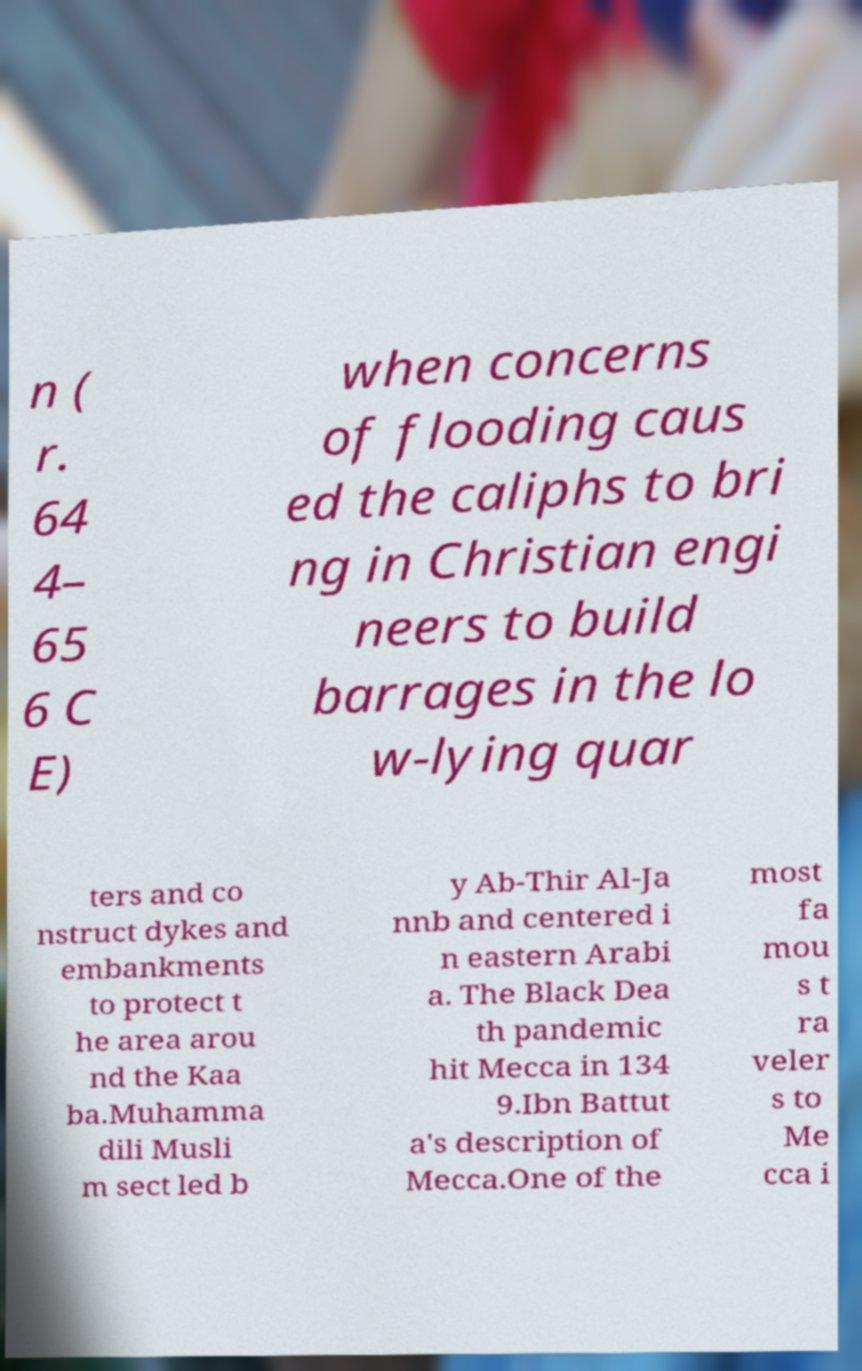Please read and relay the text visible in this image. What does it say? n ( r. 64 4– 65 6 C E) when concerns of flooding caus ed the caliphs to bri ng in Christian engi neers to build barrages in the lo w-lying quar ters and co nstruct dykes and embankments to protect t he area arou nd the Kaa ba.Muhamma dili Musli m sect led b y Ab-Thir Al-Ja nnb and centered i n eastern Arabi a. The Black Dea th pandemic hit Mecca in 134 9.Ibn Battut a's description of Mecca.One of the most fa mou s t ra veler s to Me cca i 